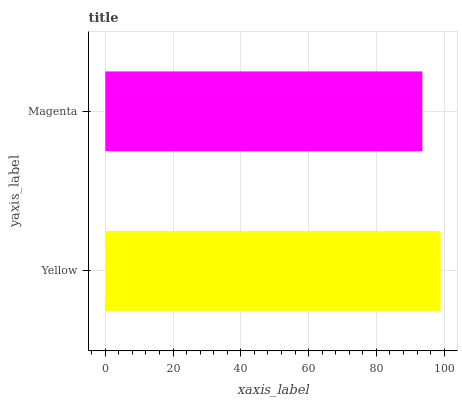Is Magenta the minimum?
Answer yes or no. Yes. Is Yellow the maximum?
Answer yes or no. Yes. Is Magenta the maximum?
Answer yes or no. No. Is Yellow greater than Magenta?
Answer yes or no. Yes. Is Magenta less than Yellow?
Answer yes or no. Yes. Is Magenta greater than Yellow?
Answer yes or no. No. Is Yellow less than Magenta?
Answer yes or no. No. Is Yellow the high median?
Answer yes or no. Yes. Is Magenta the low median?
Answer yes or no. Yes. Is Magenta the high median?
Answer yes or no. No. Is Yellow the low median?
Answer yes or no. No. 